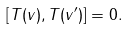<formula> <loc_0><loc_0><loc_500><loc_500>[ { T } ( v ) , { T } ( v ^ { \prime } ) ] = 0 .</formula> 